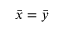<formula> <loc_0><loc_0><loc_500><loc_500>{ \bar { x } } = { \bar { y } }</formula> 